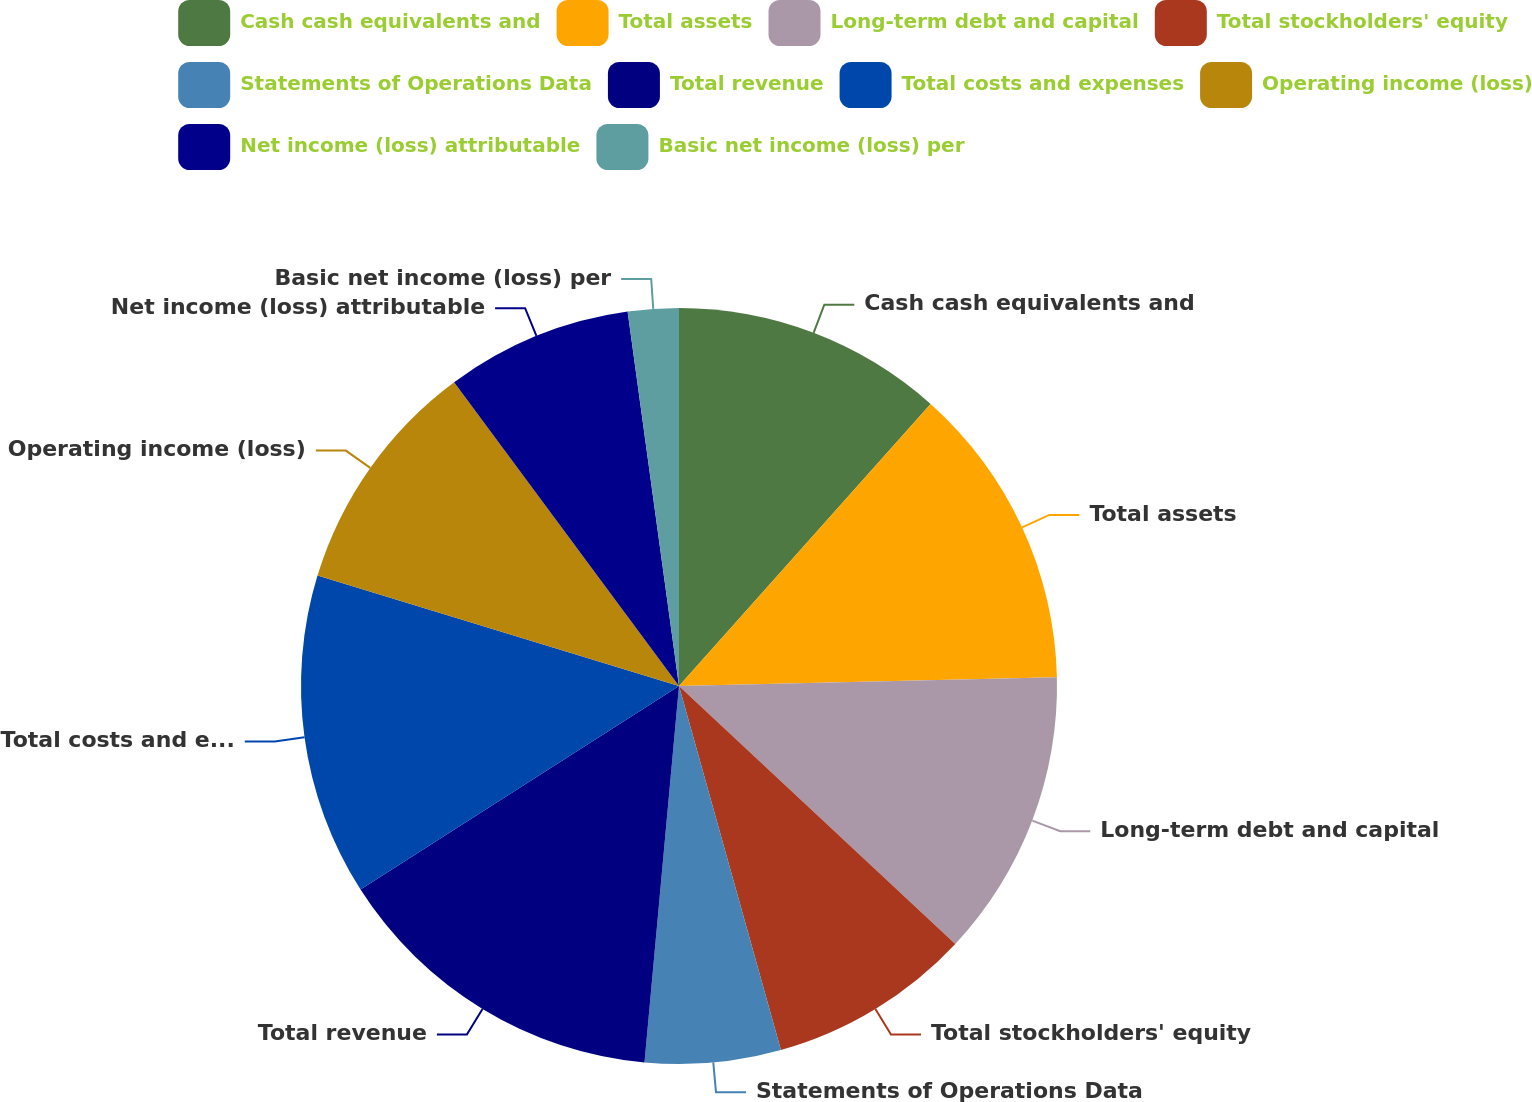<chart> <loc_0><loc_0><loc_500><loc_500><pie_chart><fcel>Cash cash equivalents and<fcel>Total assets<fcel>Long-term debt and capital<fcel>Total stockholders' equity<fcel>Statements of Operations Data<fcel>Total revenue<fcel>Total costs and expenses<fcel>Operating income (loss)<fcel>Net income (loss) attributable<fcel>Basic net income (loss) per<nl><fcel>11.59%<fcel>13.04%<fcel>12.32%<fcel>8.7%<fcel>5.8%<fcel>14.49%<fcel>13.77%<fcel>10.14%<fcel>7.97%<fcel>2.17%<nl></chart> 